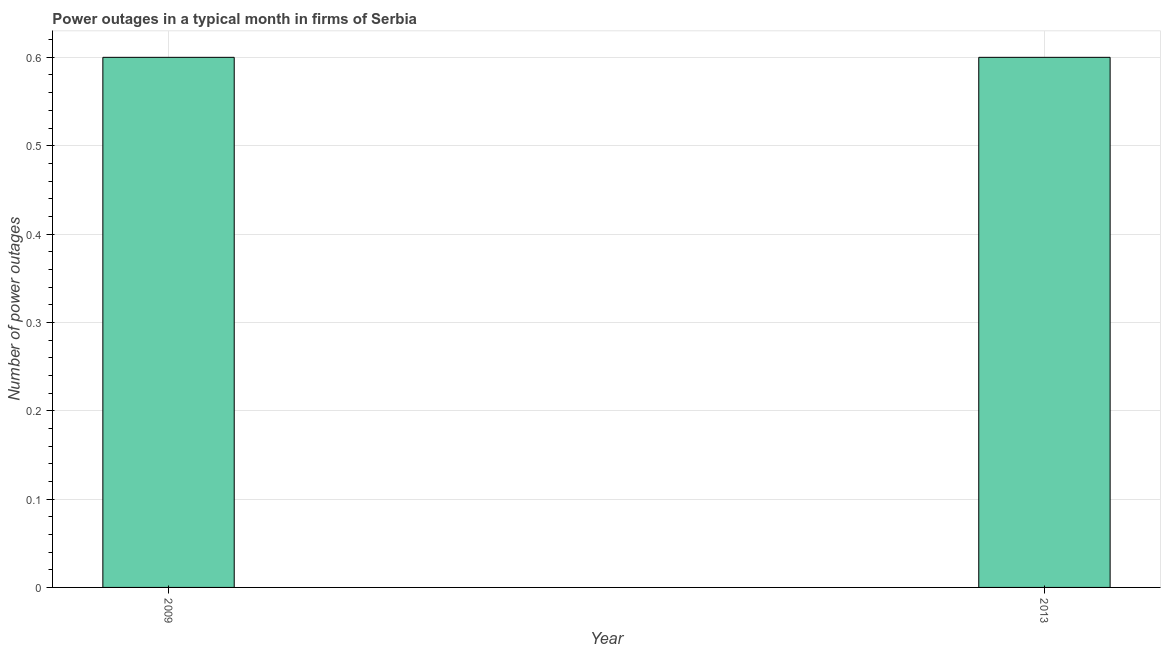Does the graph contain grids?
Ensure brevity in your answer.  Yes. What is the title of the graph?
Offer a very short reply. Power outages in a typical month in firms of Serbia. What is the label or title of the X-axis?
Your answer should be very brief. Year. What is the label or title of the Y-axis?
Your answer should be very brief. Number of power outages. What is the number of power outages in 2013?
Provide a short and direct response. 0.6. Across all years, what is the minimum number of power outages?
Offer a terse response. 0.6. In which year was the number of power outages maximum?
Keep it short and to the point. 2009. What is the difference between the number of power outages in 2009 and 2013?
Give a very brief answer. 0. What is the average number of power outages per year?
Keep it short and to the point. 0.6. What is the median number of power outages?
Offer a terse response. 0.6. In how many years, is the number of power outages greater than 0.1 ?
Provide a short and direct response. 2. How many bars are there?
Offer a terse response. 2. What is the difference between two consecutive major ticks on the Y-axis?
Your answer should be very brief. 0.1. 